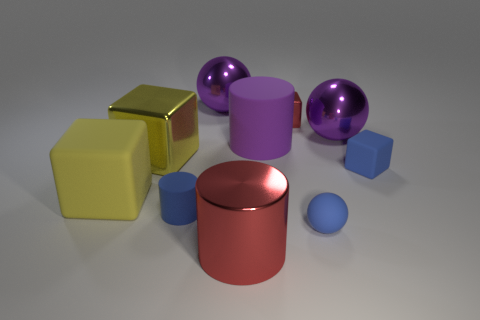Subtract all big shiny blocks. How many blocks are left? 3 Subtract all purple spheres. How many spheres are left? 1 Subtract all yellow balls. How many blue blocks are left? 1 Add 1 big purple shiny cubes. How many big purple shiny cubes exist? 1 Subtract 0 brown spheres. How many objects are left? 10 Subtract all cylinders. How many objects are left? 7 Subtract 3 cubes. How many cubes are left? 1 Subtract all purple balls. Subtract all brown cylinders. How many balls are left? 1 Subtract all big green objects. Subtract all tiny metal blocks. How many objects are left? 9 Add 5 purple spheres. How many purple spheres are left? 7 